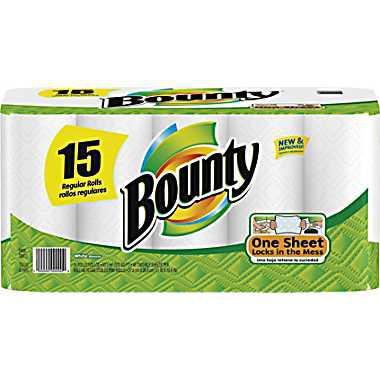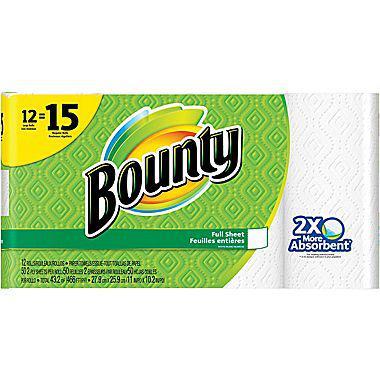The first image is the image on the left, the second image is the image on the right. Assess this claim about the two images: "One multipack of towel rolls has a yellow semi-circle in the upper left, and the other multipack has a yellow curved shape with a double-digit number on it.". Correct or not? Answer yes or no. Yes. The first image is the image on the left, the second image is the image on the right. Given the left and right images, does the statement "Every single package of paper towels claims to be 15 rolls worth." hold true? Answer yes or no. Yes. 